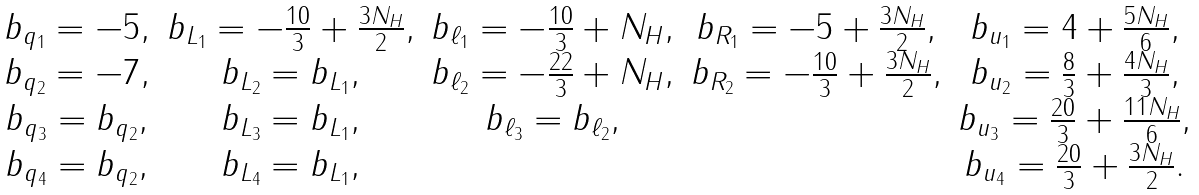Convert formula to latex. <formula><loc_0><loc_0><loc_500><loc_500>\begin{array} { c c c c c } b _ { q _ { 1 } } = - 5 , & b _ { L _ { 1 } } = - \frac { 1 0 } { 3 } + \frac { 3 N _ { H } } { 2 } , & b _ { \ell _ { 1 } } = - \frac { 1 0 } { 3 } + N _ { H } , & b _ { R _ { 1 } } = - 5 + \frac { 3 N _ { H } } { 2 } , & b _ { u _ { 1 } } = 4 + \frac { 5 N _ { H } } { 6 } , \\ b _ { q _ { 2 } } = - 7 , & b _ { L _ { 2 } } = b _ { L _ { 1 } } , & b _ { \ell _ { 2 } } = - \frac { 2 2 } { 3 } + N _ { H } , & b _ { R _ { 2 } } = - \frac { 1 0 } { 3 } + \frac { 3 N _ { H } } { 2 } , & b _ { u _ { 2 } } = \frac { 8 } { 3 } + \frac { 4 N _ { H } } { 3 } , \\ b _ { q _ { 3 } } = b _ { q _ { 2 } } , & b _ { L _ { 3 } } = b _ { L _ { 1 } } , & b _ { \ell _ { 3 } } = b _ { \ell _ { 2 } } , & & b _ { u _ { 3 } } = \frac { 2 0 } { 3 } + \frac { 1 1 N _ { H } } { 6 } , \\ b _ { q _ { 4 } } = b _ { q _ { 2 } } , & b _ { L _ { 4 } } = b _ { L _ { 1 } } , & & & b _ { u _ { 4 } } = \frac { 2 0 } { 3 } + \frac { 3 N _ { H } } { 2 } . \end{array}</formula> 